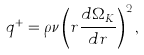Convert formula to latex. <formula><loc_0><loc_0><loc_500><loc_500>q ^ { + } = \rho \nu \left ( r \frac { d \Omega _ { K } } { d r } \right ) ^ { 2 } ,</formula> 